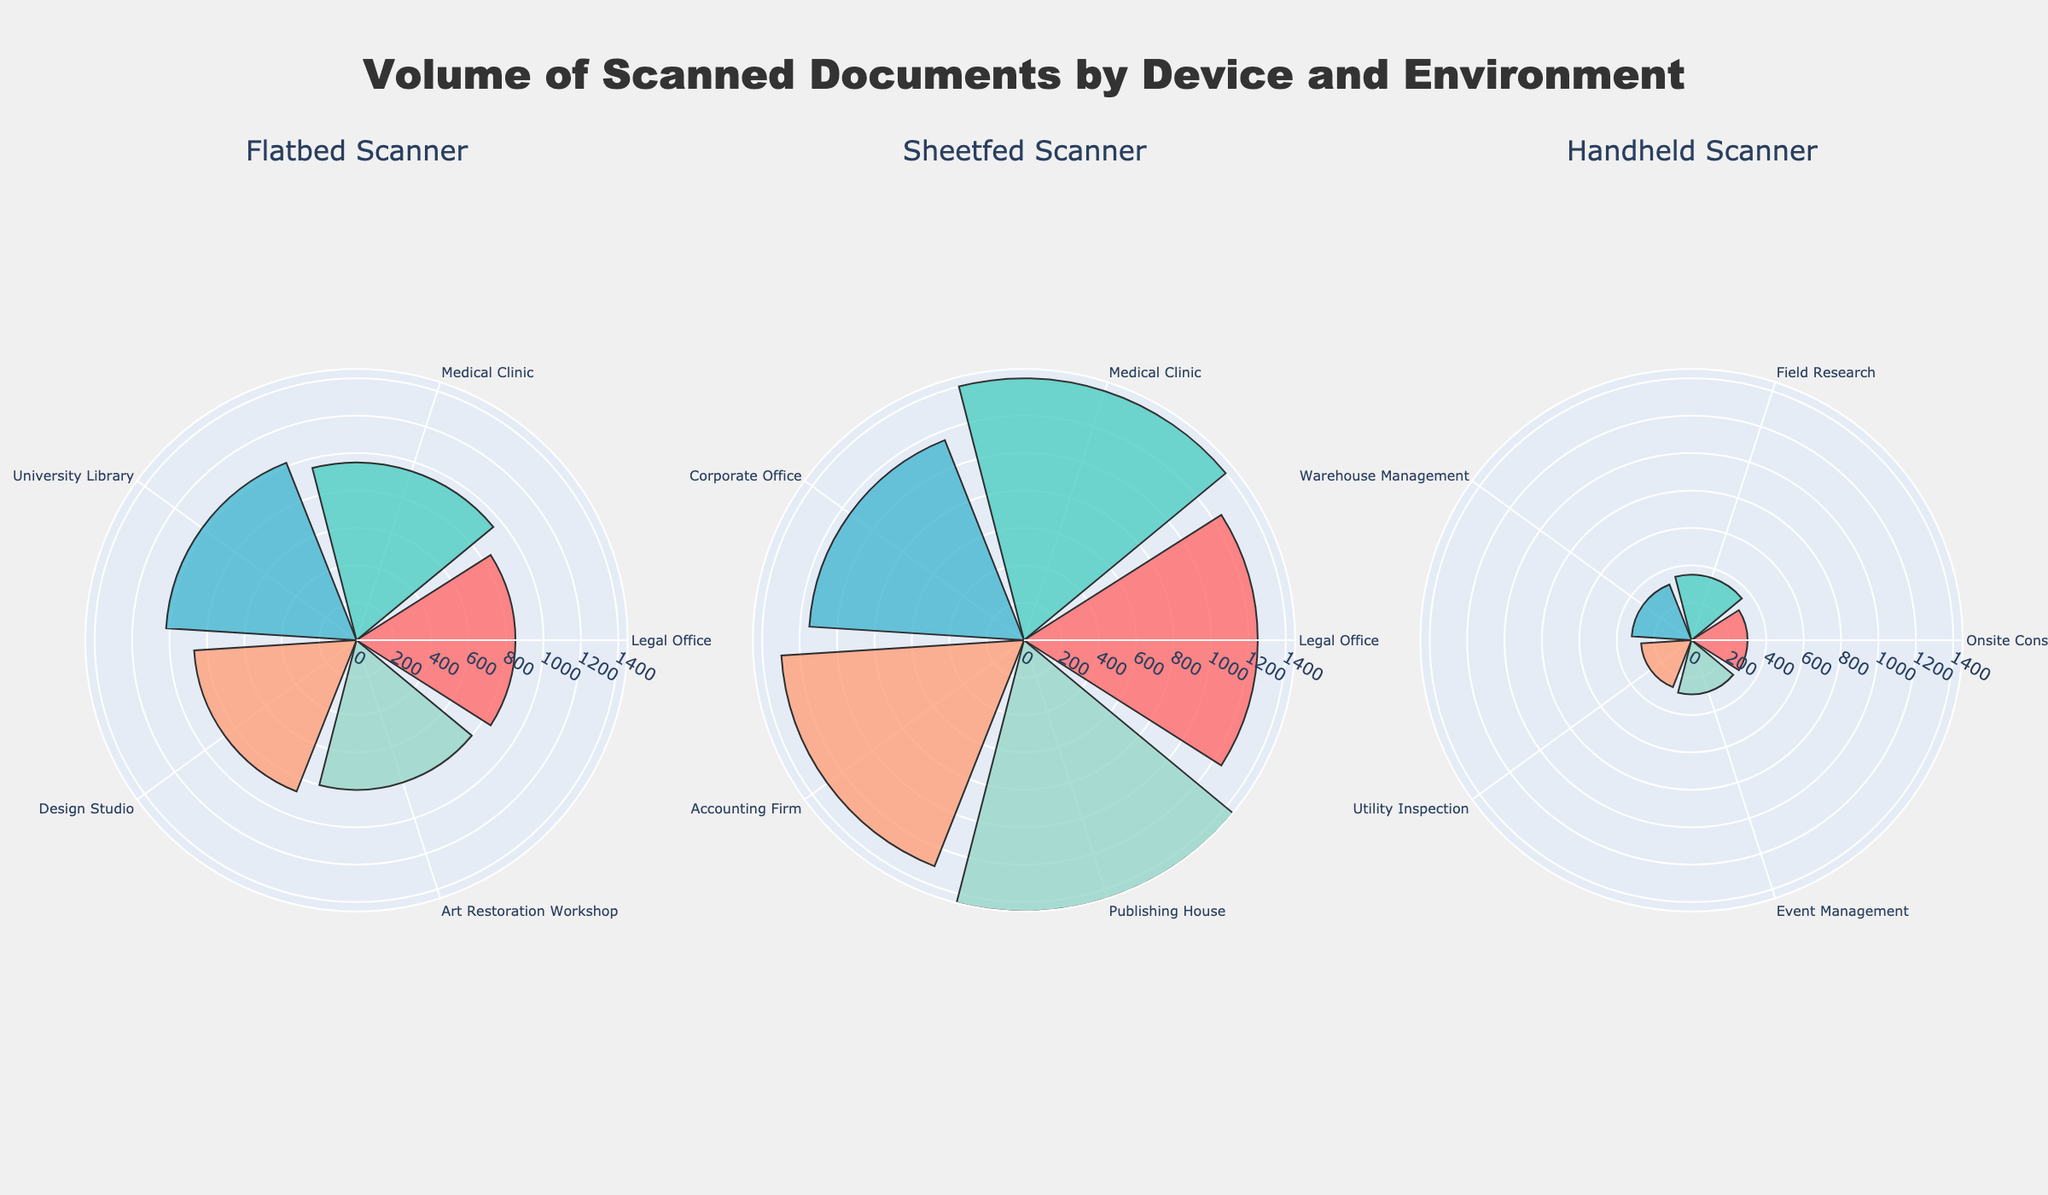What's the title of the figure? The title of the figure is displayed at the top center of the chart.
Answer: Volume of Scanned Documents by Device and Environment How many workflow environments are shown in the figure for handheld scanners? Each radial segment represents a different workflow environment. Count the radial segments under the subplot for handheld scanners.
Answer: 5 Which scanning device has the highest volume of scanned documents in a single workflow environment? Compare the lengths of the radial bars for each device. The longest bar represents the highest volume.
Answer: Sheetfed Scanner What's the average volume of scanned documents for flatbed scanners? Sum the volumes of scanned documents for flatbed scanners and divide by the number of workflow environments represented for flatbed scanners. (850+950+1020+870+800) / 5 = 4490 / 5 = 898
Answer: 898 Which workflow environment has the highest volume of scanned documents for sheetfed scanners? Look at the subplot for sheetfed scanners and identify the environment with the longest bar.
Answer: Publishing House What's the combined volume of scanned documents for handheld scanners in "Event Management" and "Warehouse Management"? Find the volumes for "Event Management" and "Warehouse Management" in the subplot for handheld scanners and sum them up. 290 + 320 = 610
Answer: 610 Compare the total volumes of scanned documents between flatbed scanners and handheld scanners. Which device scans more? Sum the volumes of scanned documents for each workflow environment represented for flatbed and handheld scanners. Compare the two totals.
Flatbed: 850 + 950 + 1020 + 870 + 800 = 4490
Handheld: 300 + 350 + 320 + 270 + 290 = 1530 
Flatbed scanners scan more documents in total.
Answer: Flatbed scanners Which scanning device has the most diverse workflow environments? Count the number of different workflow environment names in each subplot. The device with the most unique environment names is the answer.
Answer: Sheetfed Scanner 